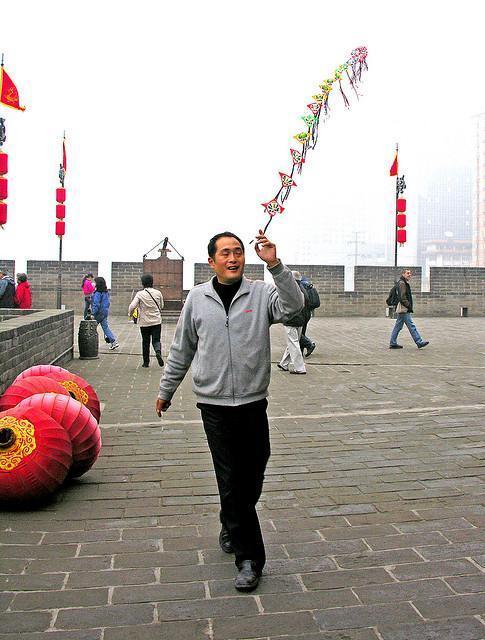How many people are in the photo?
Give a very brief answer. 2. 